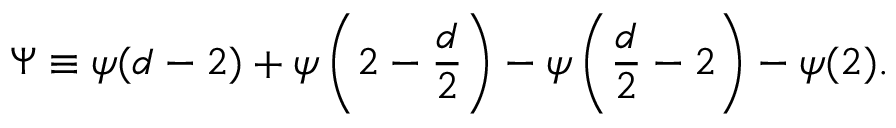<formula> <loc_0><loc_0><loc_500><loc_500>\Psi \equiv \psi ( d - 2 ) + \psi \left ( 2 - { \frac { d } { 2 } } \right ) - \psi \left ( { \frac { d } { 2 } } - 2 \right ) - \psi ( 2 ) .</formula> 